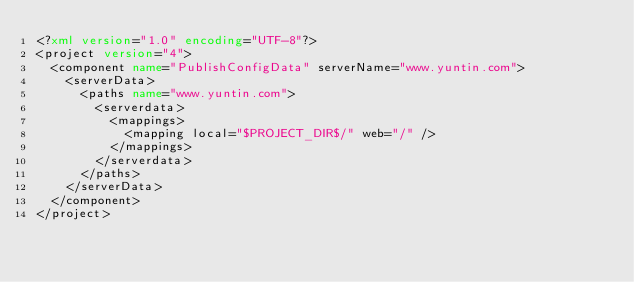Convert code to text. <code><loc_0><loc_0><loc_500><loc_500><_XML_><?xml version="1.0" encoding="UTF-8"?>
<project version="4">
  <component name="PublishConfigData" serverName="www.yuntin.com">
    <serverData>
      <paths name="www.yuntin.com">
        <serverdata>
          <mappings>
            <mapping local="$PROJECT_DIR$/" web="/" />
          </mappings>
        </serverdata>
      </paths>
    </serverData>
  </component>
</project></code> 